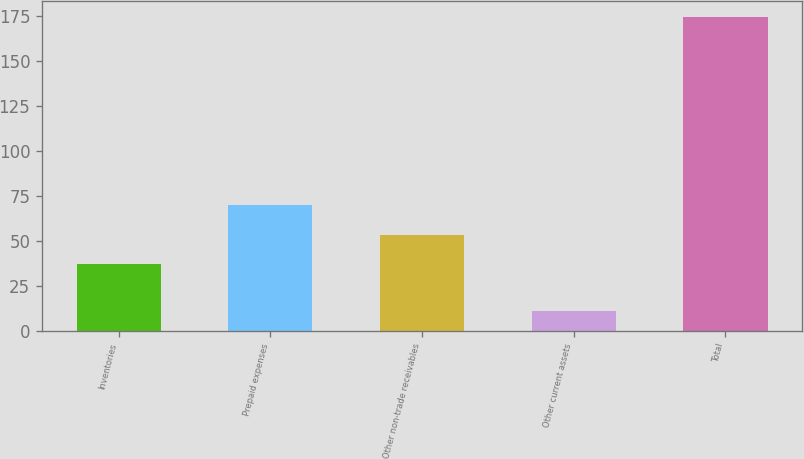Convert chart. <chart><loc_0><loc_0><loc_500><loc_500><bar_chart><fcel>Inventories<fcel>Prepaid expenses<fcel>Other non-trade receivables<fcel>Other current assets<fcel>Total<nl><fcel>37.1<fcel>69.88<fcel>53.49<fcel>10.8<fcel>174.7<nl></chart> 